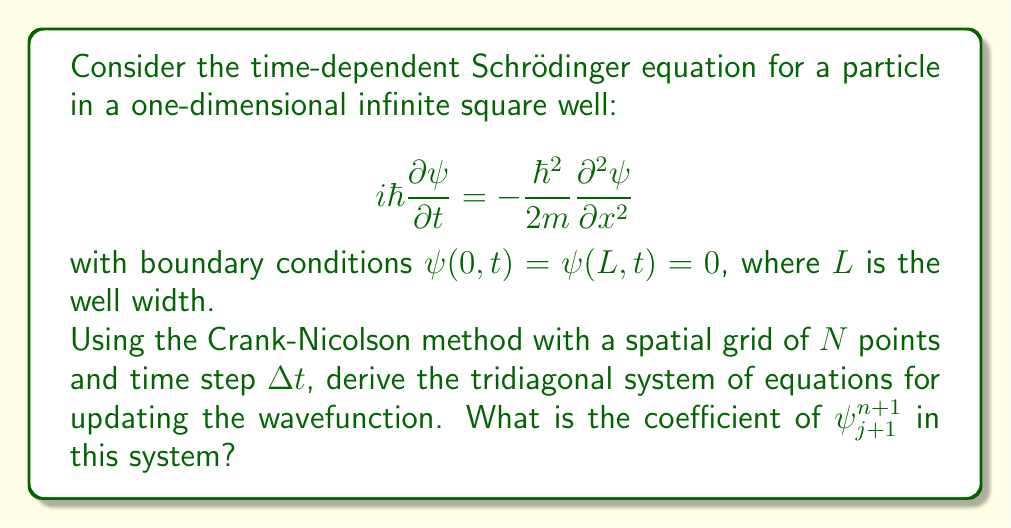Solve this math problem. Let's approach this step-by-step:

1) First, we discretize space and time: $x_j = j\Delta x$ where $\Delta x = L/N$, and $t_n = n\Delta t$.

2) The Crank-Nicolson method uses the average of forward and backward differences in time:

   $$i\hbar\frac{\psi_j^{n+1} - \psi_j^n}{\Delta t} = -\frac{\hbar^2}{4m}\left(\frac{\partial^2\psi}{\partial x^2}\right)_j^{n+1} - \frac{\hbar^2}{4m}\left(\frac{\partial^2\psi}{\partial x^2}\right)_j^n$$

3) We use the central difference for the spatial second derivative:

   $$\left(\frac{\partial^2\psi}{\partial x^2}\right)_j \approx \frac{\psi_{j+1} - 2\psi_j + \psi_{j-1}}{(\Delta x)^2}$$

4) Substituting this into the Crank-Nicolson equation:

   $$i\hbar\frac{\psi_j^{n+1} - \psi_j^n}{\Delta t} = -\frac{\hbar^2}{4m(\Delta x)^2}(\psi_{j+1}^{n+1} - 2\psi_j^{n+1} + \psi_{j-1}^{n+1}) - \frac{\hbar^2}{4m(\Delta x)^2}(\psi_{j+1}^n - 2\psi_j^n + \psi_{j-1}^n)$$

5) Let $r = \frac{i\hbar\Delta t}{2m(\Delta x)^2}$. Multiplying both sides by $\Delta t$ and rearranging:

   $$-r\psi_{j-1}^{n+1} + (2i+2r)\psi_j^{n+1} - r\psi_{j+1}^{n+1} = r\psi_{j-1}^n + (2i-2r)\psi_j^n + r\psi_{j+1}^n$$

6) This forms a tridiagonal system of equations. The coefficient of $\psi_{j+1}^{n+1}$ is $-r$.
Answer: $-r = -\frac{i\hbar\Delta t}{2m(\Delta x)^2}$ 